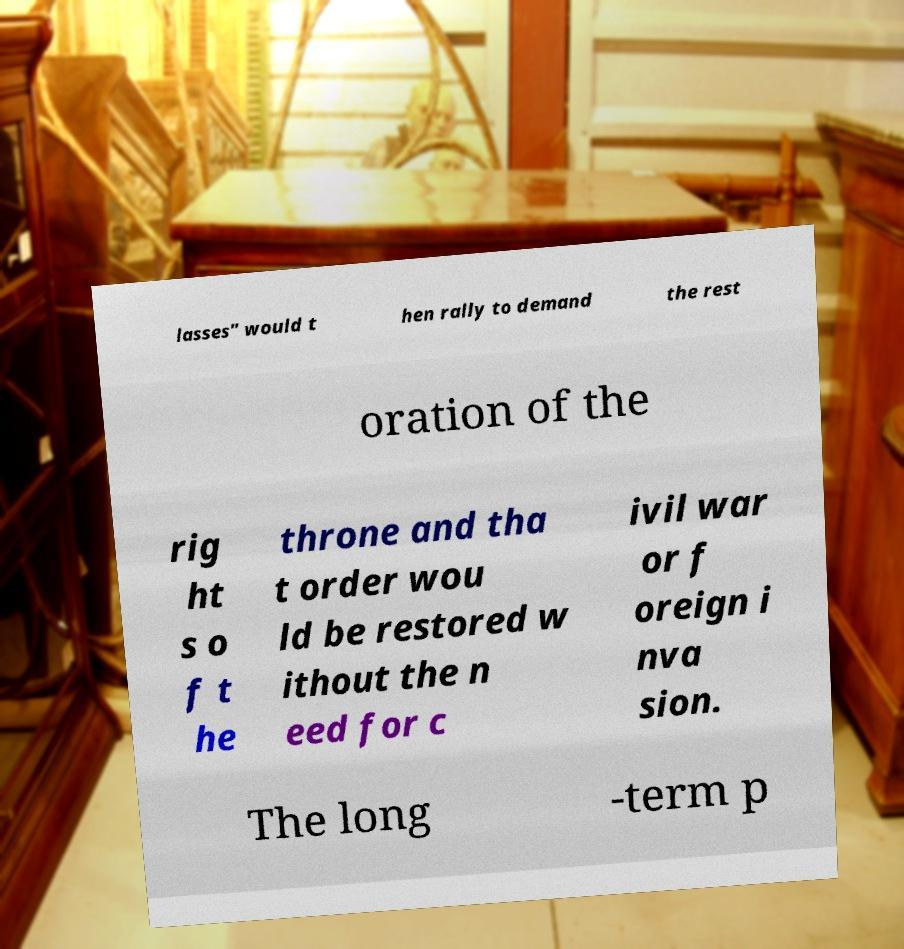There's text embedded in this image that I need extracted. Can you transcribe it verbatim? lasses" would t hen rally to demand the rest oration of the rig ht s o f t he throne and tha t order wou ld be restored w ithout the n eed for c ivil war or f oreign i nva sion. The long -term p 